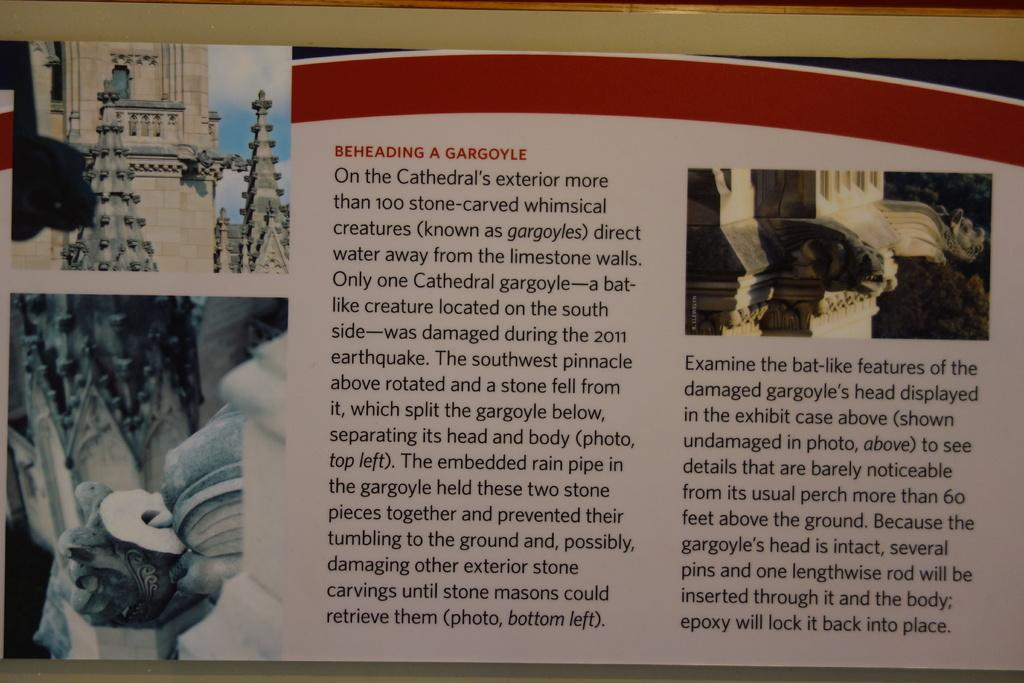Provide a one-sentence caption for the provided image. PAGES OF A BOOK WITH PICTURES WITH A STORY ABOUT BEHEADING GARGOYLE. 